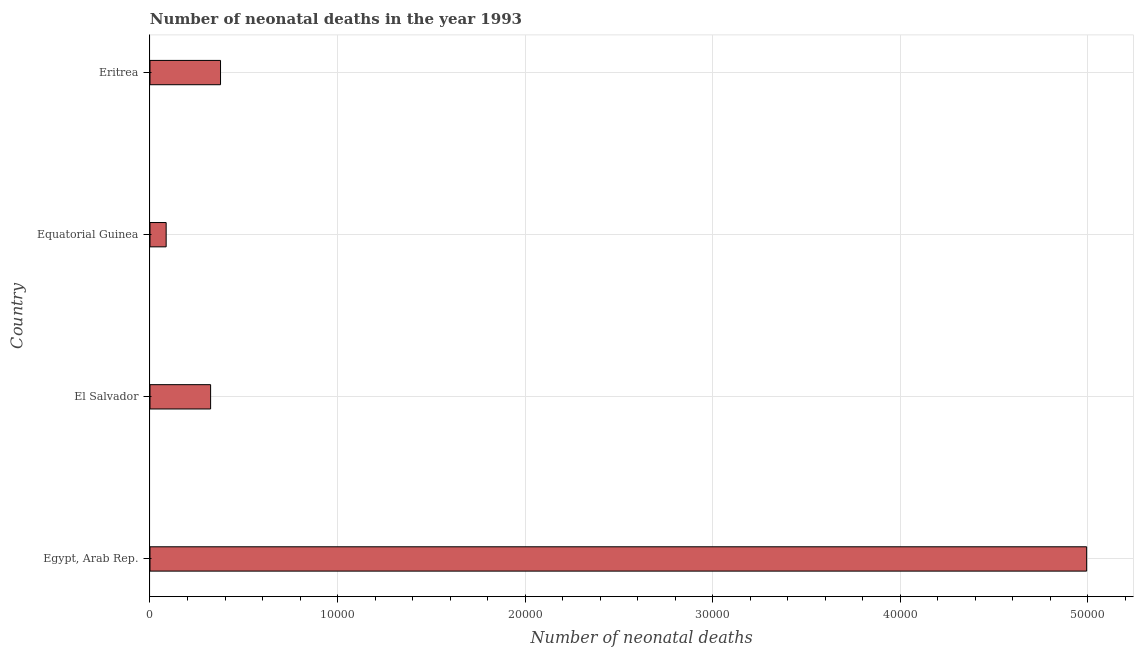Does the graph contain grids?
Offer a terse response. Yes. What is the title of the graph?
Ensure brevity in your answer.  Number of neonatal deaths in the year 1993. What is the label or title of the X-axis?
Your answer should be very brief. Number of neonatal deaths. What is the label or title of the Y-axis?
Make the answer very short. Country. What is the number of neonatal deaths in El Salvador?
Offer a terse response. 3232. Across all countries, what is the maximum number of neonatal deaths?
Ensure brevity in your answer.  4.99e+04. Across all countries, what is the minimum number of neonatal deaths?
Make the answer very short. 862. In which country was the number of neonatal deaths maximum?
Make the answer very short. Egypt, Arab Rep. In which country was the number of neonatal deaths minimum?
Make the answer very short. Equatorial Guinea. What is the sum of the number of neonatal deaths?
Offer a very short reply. 5.78e+04. What is the difference between the number of neonatal deaths in Egypt, Arab Rep. and Equatorial Guinea?
Ensure brevity in your answer.  4.91e+04. What is the average number of neonatal deaths per country?
Keep it short and to the point. 1.44e+04. What is the median number of neonatal deaths?
Your answer should be compact. 3496.5. In how many countries, is the number of neonatal deaths greater than 4000 ?
Your answer should be compact. 1. What is the ratio of the number of neonatal deaths in Egypt, Arab Rep. to that in Equatorial Guinea?
Ensure brevity in your answer.  57.94. What is the difference between the highest and the second highest number of neonatal deaths?
Provide a short and direct response. 4.62e+04. What is the difference between the highest and the lowest number of neonatal deaths?
Ensure brevity in your answer.  4.91e+04. In how many countries, is the number of neonatal deaths greater than the average number of neonatal deaths taken over all countries?
Your response must be concise. 1. How many countries are there in the graph?
Your response must be concise. 4. What is the difference between two consecutive major ticks on the X-axis?
Your answer should be compact. 10000. What is the Number of neonatal deaths in Egypt, Arab Rep.?
Offer a terse response. 4.99e+04. What is the Number of neonatal deaths of El Salvador?
Keep it short and to the point. 3232. What is the Number of neonatal deaths in Equatorial Guinea?
Offer a very short reply. 862. What is the Number of neonatal deaths of Eritrea?
Provide a short and direct response. 3761. What is the difference between the Number of neonatal deaths in Egypt, Arab Rep. and El Salvador?
Ensure brevity in your answer.  4.67e+04. What is the difference between the Number of neonatal deaths in Egypt, Arab Rep. and Equatorial Guinea?
Your answer should be very brief. 4.91e+04. What is the difference between the Number of neonatal deaths in Egypt, Arab Rep. and Eritrea?
Offer a terse response. 4.62e+04. What is the difference between the Number of neonatal deaths in El Salvador and Equatorial Guinea?
Your response must be concise. 2370. What is the difference between the Number of neonatal deaths in El Salvador and Eritrea?
Keep it short and to the point. -529. What is the difference between the Number of neonatal deaths in Equatorial Guinea and Eritrea?
Your response must be concise. -2899. What is the ratio of the Number of neonatal deaths in Egypt, Arab Rep. to that in El Salvador?
Your answer should be compact. 15.45. What is the ratio of the Number of neonatal deaths in Egypt, Arab Rep. to that in Equatorial Guinea?
Provide a short and direct response. 57.94. What is the ratio of the Number of neonatal deaths in Egypt, Arab Rep. to that in Eritrea?
Ensure brevity in your answer.  13.28. What is the ratio of the Number of neonatal deaths in El Salvador to that in Equatorial Guinea?
Give a very brief answer. 3.75. What is the ratio of the Number of neonatal deaths in El Salvador to that in Eritrea?
Your answer should be very brief. 0.86. What is the ratio of the Number of neonatal deaths in Equatorial Guinea to that in Eritrea?
Your answer should be very brief. 0.23. 